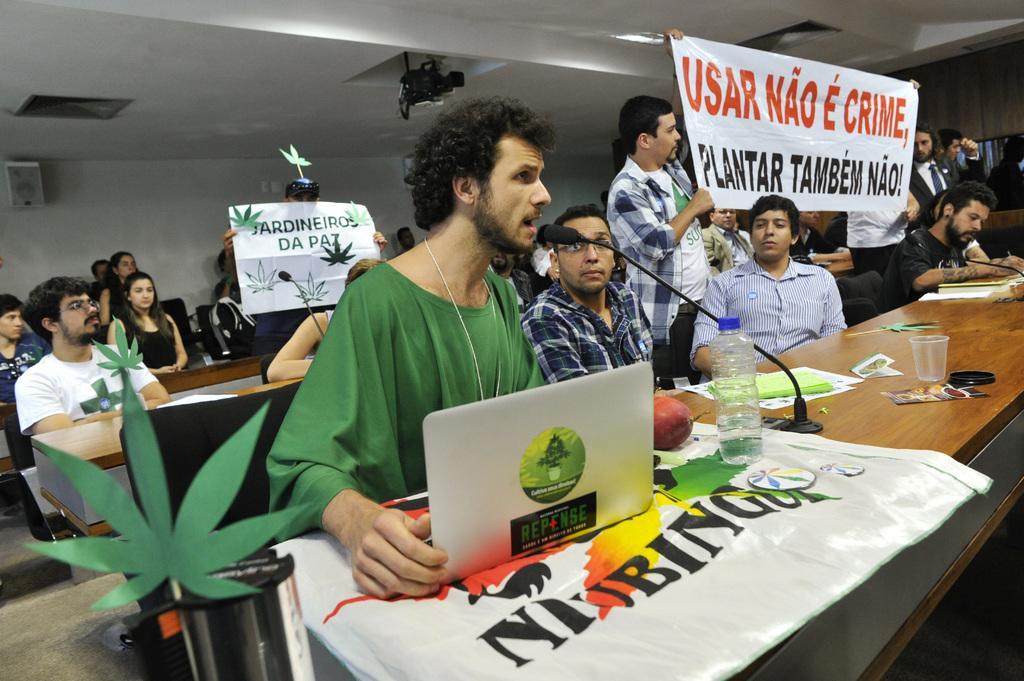How would you summarize this image in a sentence or two? In this image, we can see people and some are sitting on the chairs and some are holding banners and there is some text on them and we can see a laptop, mic, a bottle, a banner and some other objects and some decor items are on the tables. At the top, there is a roof and an object. At the bottom, there is a floor. 